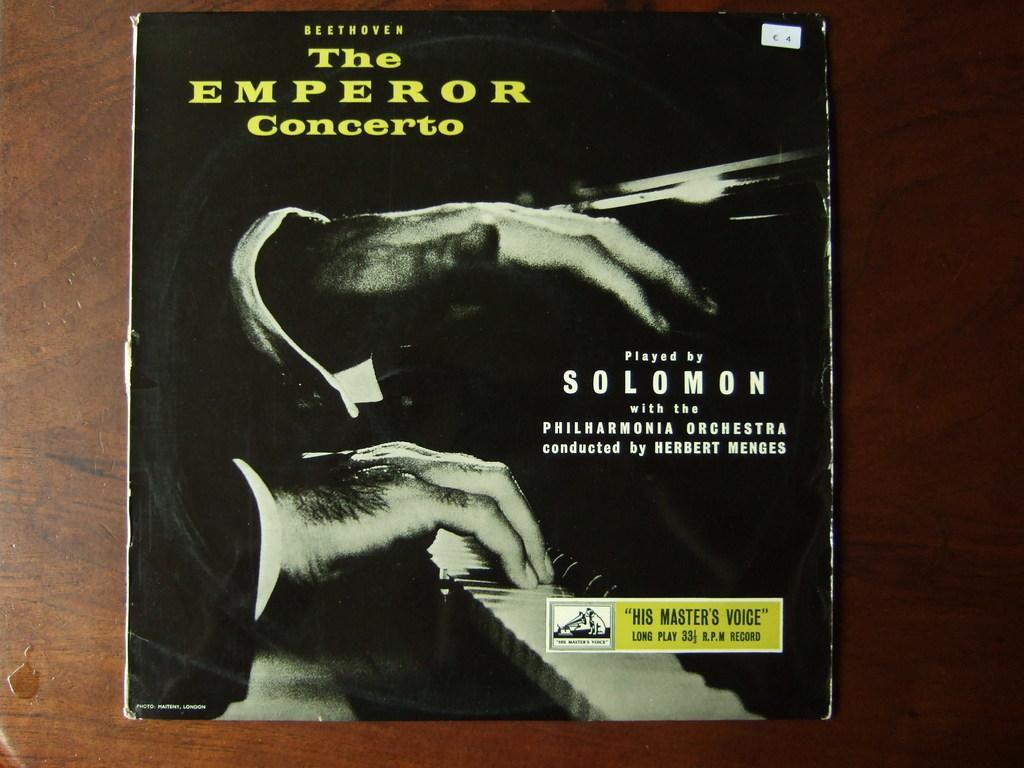Provide a one-sentence caption for the provided image. An album titled the emperor concerto presented by solomon. 